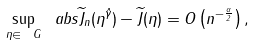<formula> <loc_0><loc_0><loc_500><loc_500>\sup _ { \eta \in \ G } \ a b s { \widetilde { J } _ { n } ( \eta ^ { \hat { \gamma } } ) - \widetilde { J } ( \eta ) } = O \left ( n ^ { - \frac { \alpha } { 2 } } \right ) ,</formula> 